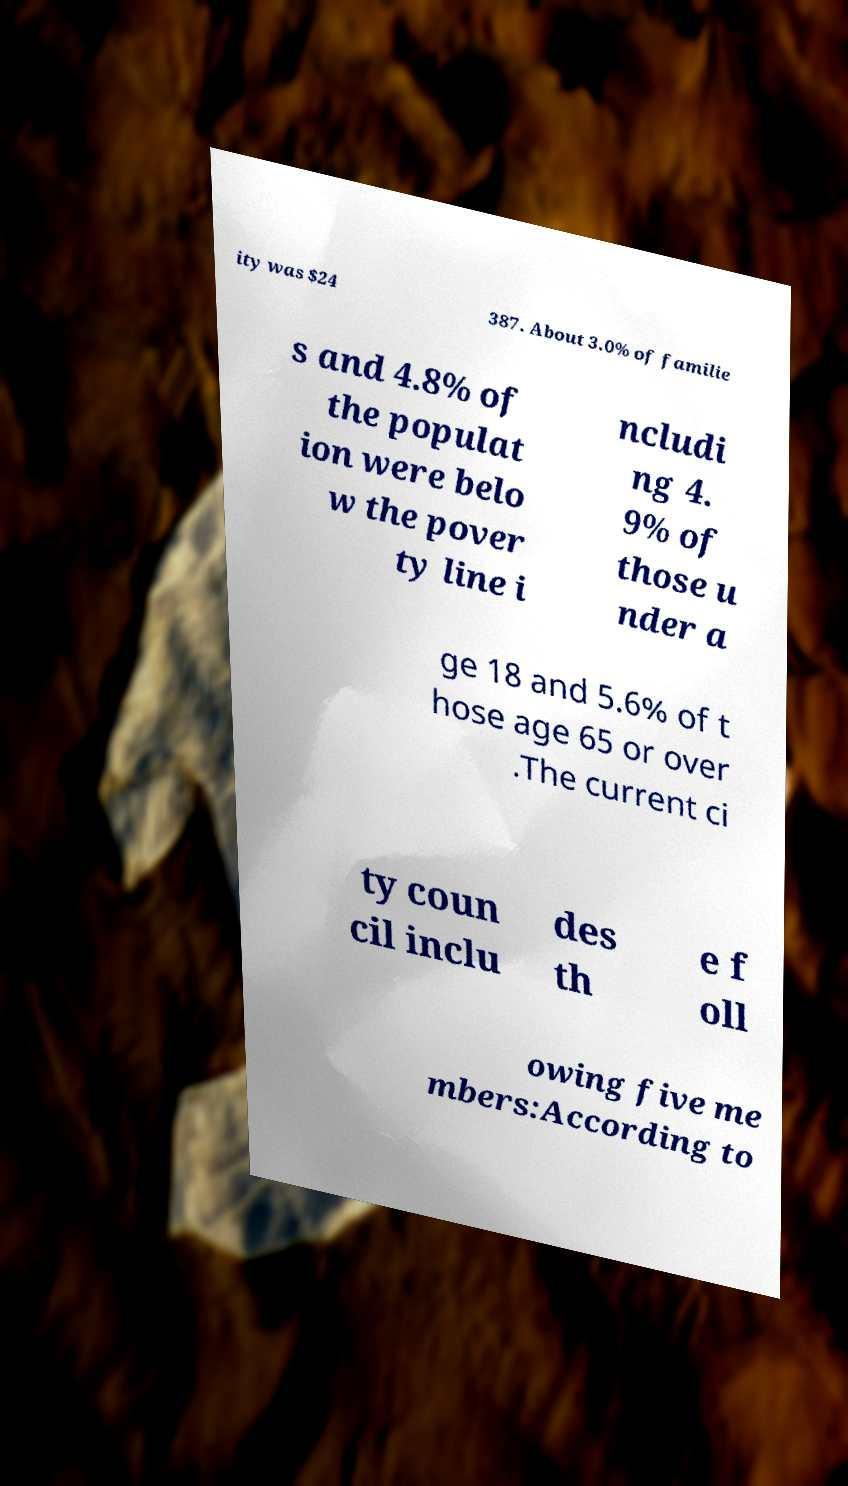Could you extract and type out the text from this image? ity was $24 387. About 3.0% of familie s and 4.8% of the populat ion were belo w the pover ty line i ncludi ng 4. 9% of those u nder a ge 18 and 5.6% of t hose age 65 or over .The current ci ty coun cil inclu des th e f oll owing five me mbers:According to 